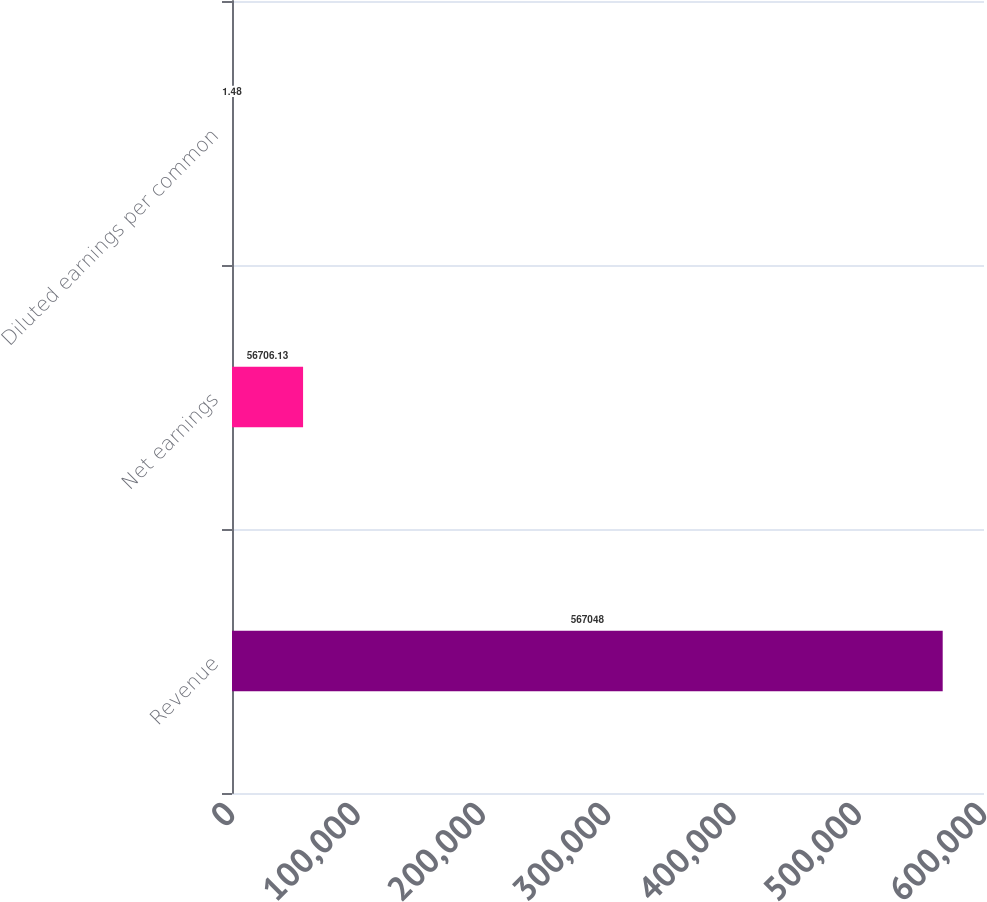<chart> <loc_0><loc_0><loc_500><loc_500><bar_chart><fcel>Revenue<fcel>Net earnings<fcel>Diluted earnings per common<nl><fcel>567048<fcel>56706.1<fcel>1.48<nl></chart> 